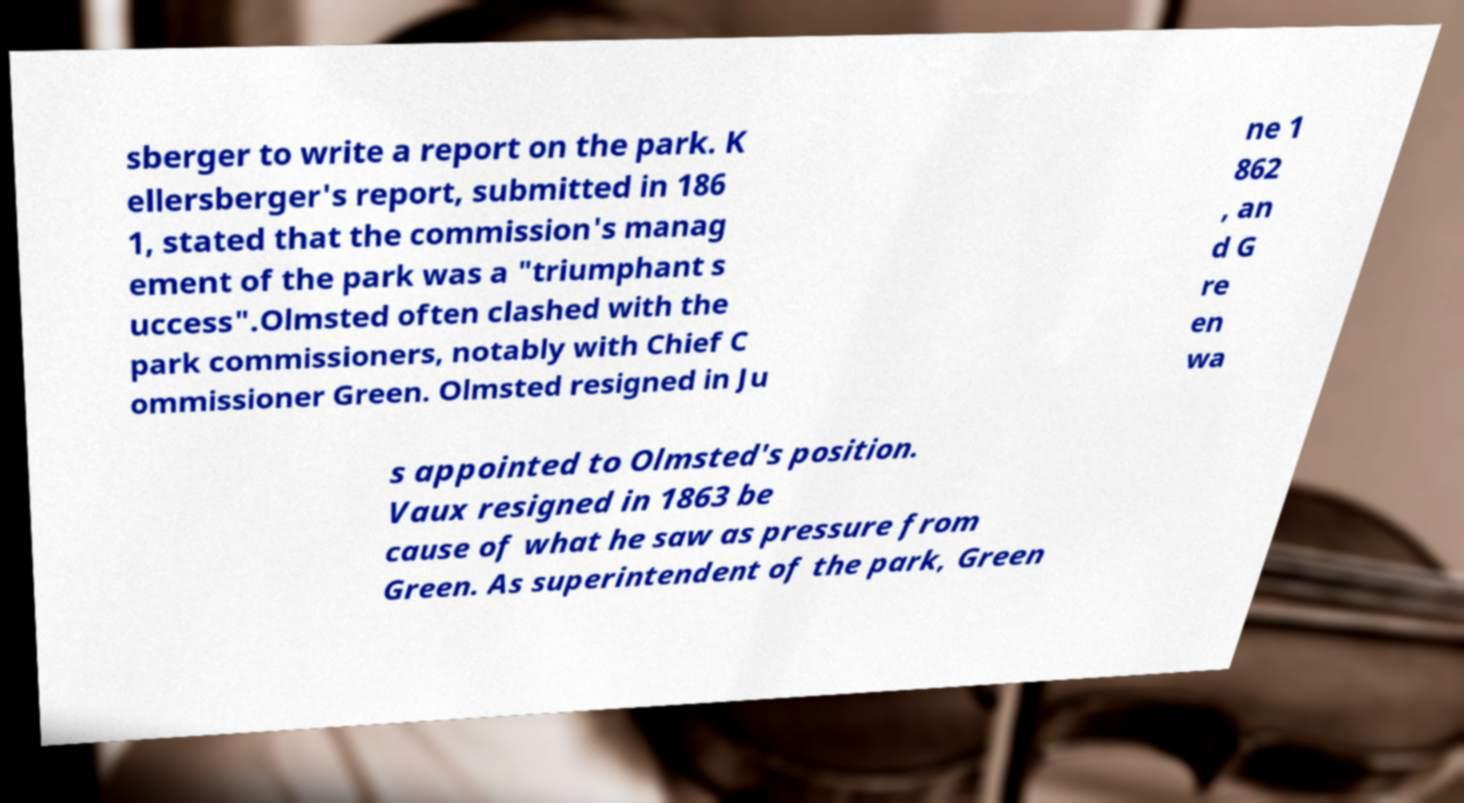Can you accurately transcribe the text from the provided image for me? sberger to write a report on the park. K ellersberger's report, submitted in 186 1, stated that the commission's manag ement of the park was a "triumphant s uccess".Olmsted often clashed with the park commissioners, notably with Chief C ommissioner Green. Olmsted resigned in Ju ne 1 862 , an d G re en wa s appointed to Olmsted's position. Vaux resigned in 1863 be cause of what he saw as pressure from Green. As superintendent of the park, Green 